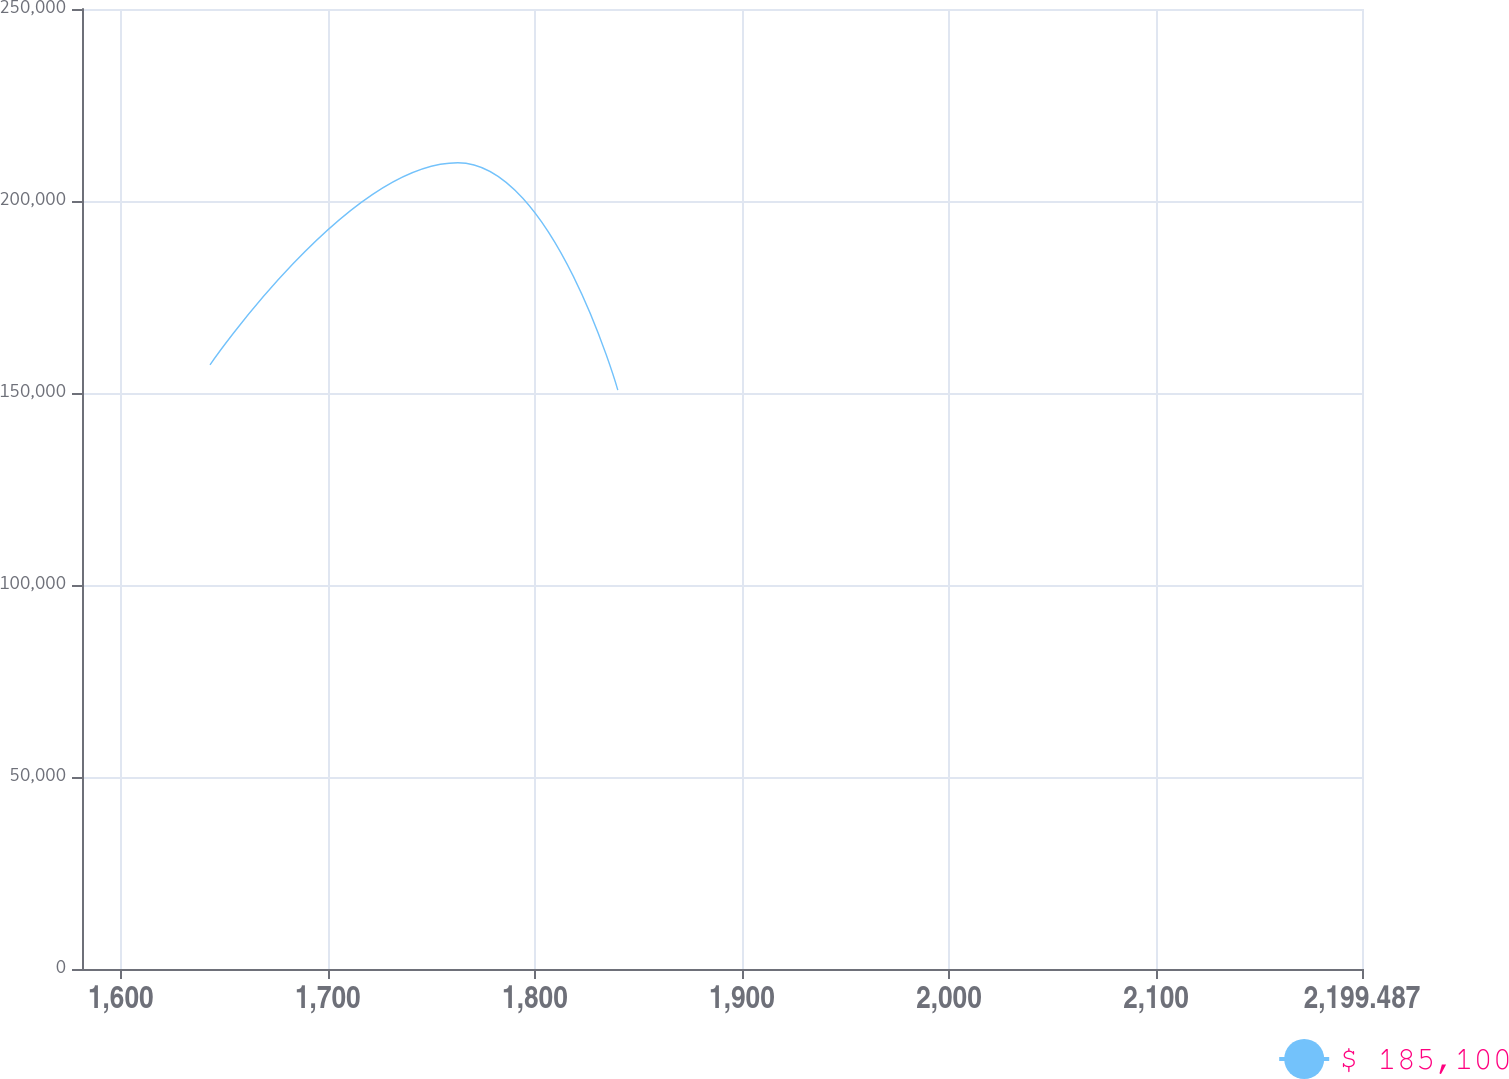<chart> <loc_0><loc_0><loc_500><loc_500><line_chart><ecel><fcel>$ 185,100<nl><fcel>1643.08<fcel>157326<nl><fcel>1762.77<fcel>209971<nl><fcel>1840.05<fcel>150745<nl><fcel>2261.31<fcel>144165<nl></chart> 